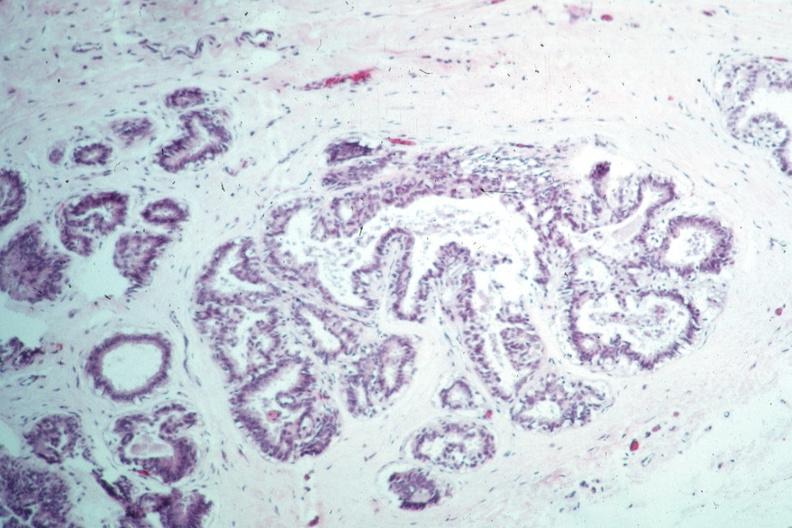what is present?
Answer the question using a single word or phrase. Intraductal papillomatosis with apocrine metaplasia 